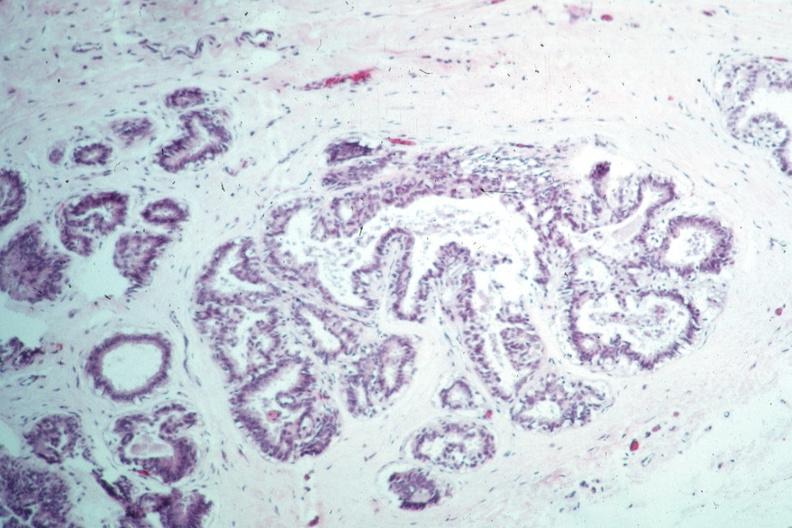what is present?
Answer the question using a single word or phrase. Intraductal papillomatosis with apocrine metaplasia 